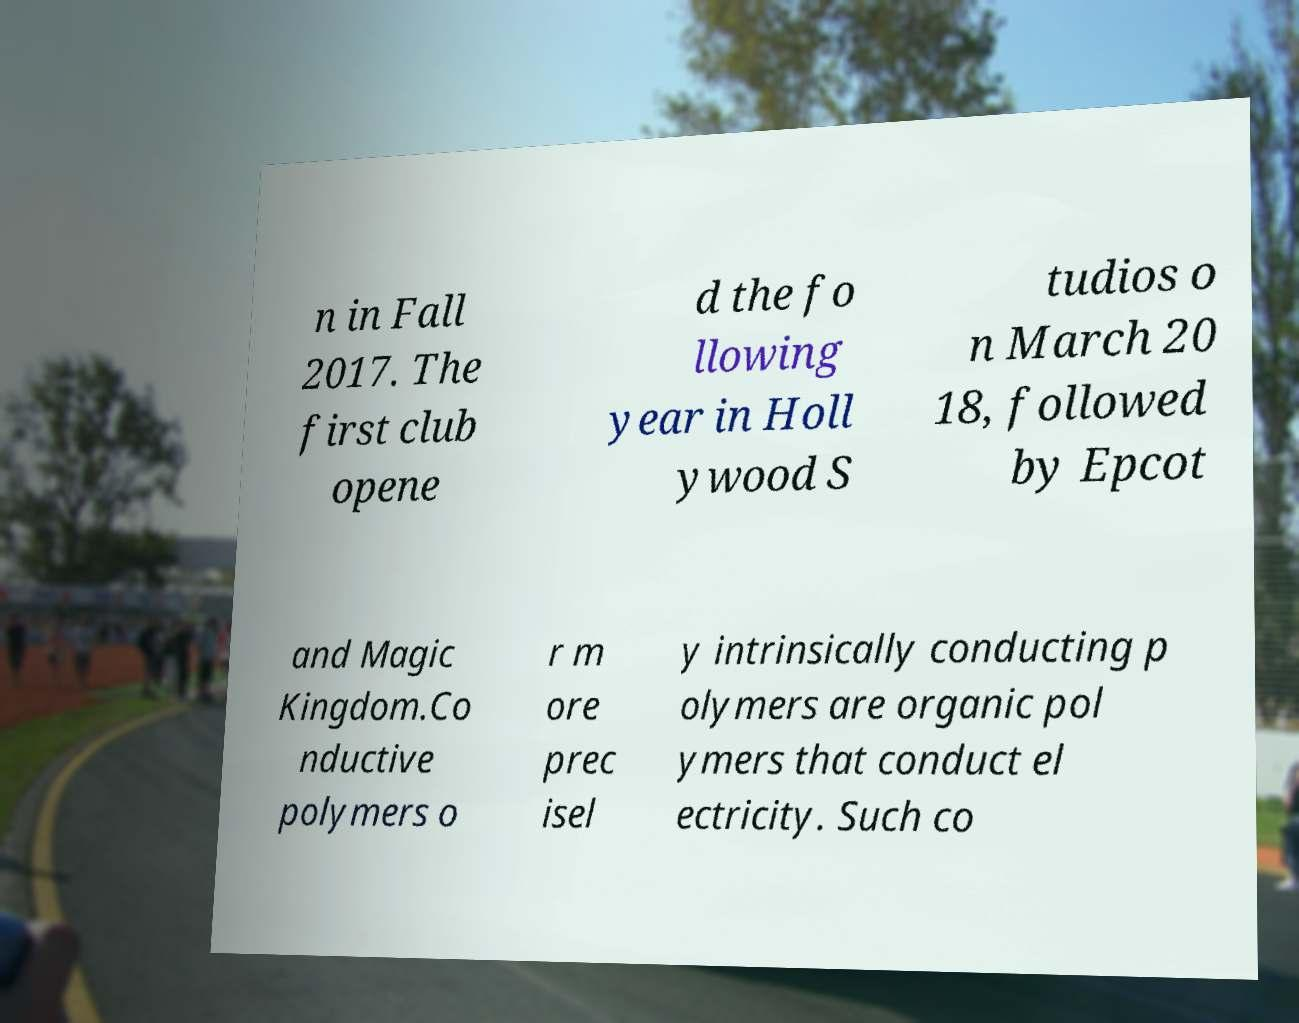Can you accurately transcribe the text from the provided image for me? n in Fall 2017. The first club opene d the fo llowing year in Holl ywood S tudios o n March 20 18, followed by Epcot and Magic Kingdom.Co nductive polymers o r m ore prec isel y intrinsically conducting p olymers are organic pol ymers that conduct el ectricity. Such co 